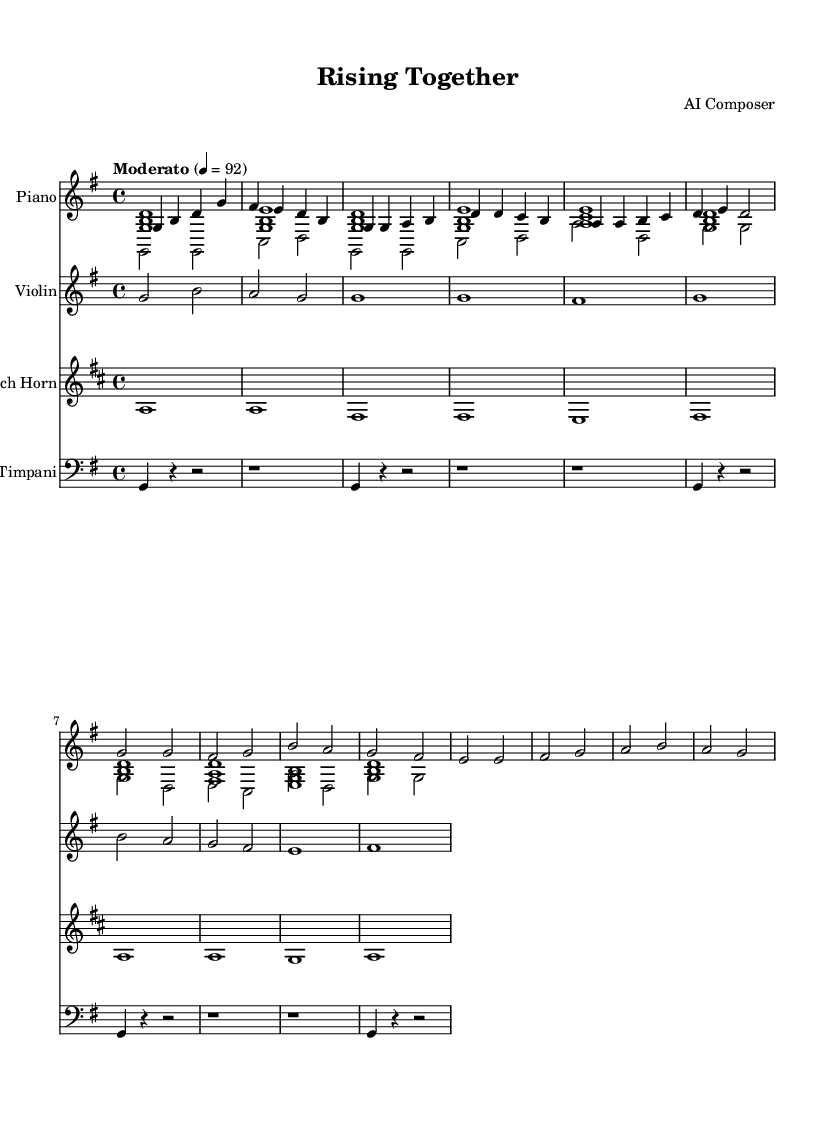What is the key signature of this music? The key signature is identified by the number of sharps or flats present at the beginning of the staff. In this case, there are no sharps or flats indicated, which means the music is in the key of G major.
Answer: G major What is the time signature of this music? The time signature is represented as two numbers at the beginning of the staff; the upper number indicates beats per measure, and the lower number indicates the note value that receives one beat. Here, the time signature reads "4/4," meaning there are four beats per measure and the quarter note gets one beat.
Answer: 4/4 What is the tempo marking for this music? The tempo marking is provided above the staff, indicating the pace of the music. In this score, it states "Moderato" followed by a metronome marking of 92, which suggests a moderate speed of the piece.
Answer: Moderato 92 Which instrument has the highest pitch in the score? To determine the instrument with the highest pitch, we can look at the notes written for each instrument. The violin typically plays at a higher register than the piano and French horn. By examining the highest notes, we find that the violin's range surpasses the others in this score.
Answer: Violin What is the primary theme of the music based on its title? The title of the piece is "Rising Together," which suggests themes of unity, growth, and overcoming challenges. The music's uplifting melodies and harmonies align with the idea of personal growth and collective support reflected in films focused on these themes.
Answer: Inspirational What is the most frequent rhythmic figure in the chorus? By analyzing the chorus section, we see a recurring pattern of quarter notes and half notes which creates a steady rhythmic structure. The dominant rhythmic figure throughout is the quarter note, contributing to the driving forward motion of the theme.
Answer: Quarter note How many measures are in the verse section? Counting the measures in the verse section, we observe it consists of six measures, allowing it to develop the thematic material before leading into the chorus. This division reflects common song structure practices in film scores.
Answer: Six measures 